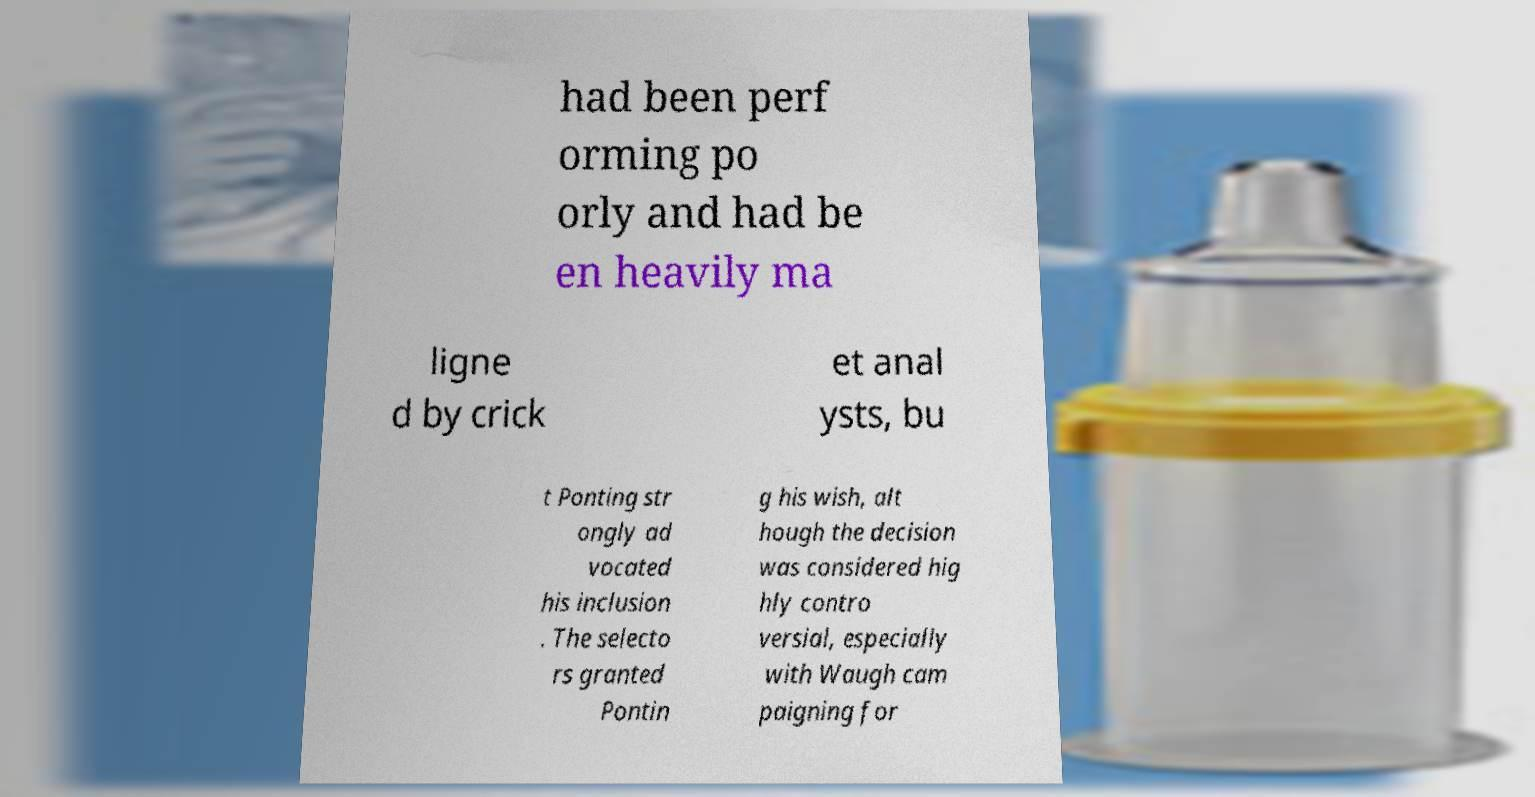Please read and relay the text visible in this image. What does it say? had been perf orming po orly and had be en heavily ma ligne d by crick et anal ysts, bu t Ponting str ongly ad vocated his inclusion . The selecto rs granted Pontin g his wish, alt hough the decision was considered hig hly contro versial, especially with Waugh cam paigning for 